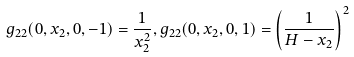<formula> <loc_0><loc_0><loc_500><loc_500>g _ { 2 2 } ( 0 , x _ { 2 } , 0 , - 1 ) = \frac { 1 } { x _ { 2 } ^ { 2 } } , g _ { 2 2 } ( 0 , x _ { 2 } , 0 , 1 ) = \left ( \frac { 1 } { H - x _ { 2 } } \right ) ^ { 2 }</formula> 